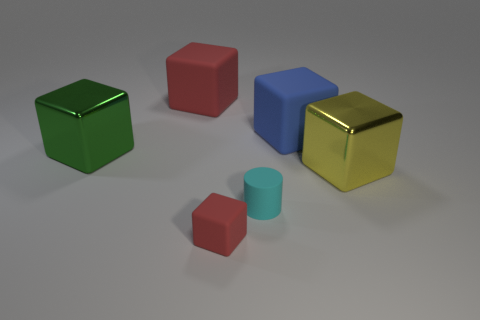Add 2 big blue matte cubes. How many objects exist? 8 Subtract all large yellow blocks. How many blocks are left? 4 Subtract all brown balls. How many red cubes are left? 2 Subtract all blue cubes. How many cubes are left? 4 Subtract all cubes. How many objects are left? 1 Subtract 1 blocks. How many blocks are left? 4 Subtract all purple cylinders. Subtract all gray balls. How many cylinders are left? 1 Subtract all big things. Subtract all green things. How many objects are left? 1 Add 1 large blocks. How many large blocks are left? 5 Add 4 tiny green matte things. How many tiny green matte things exist? 4 